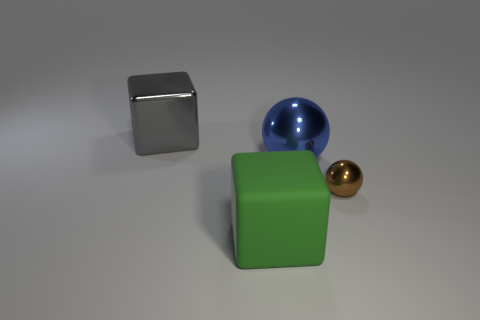Is the number of metal objects right of the large green matte object less than the number of gray shiny cubes on the right side of the small brown metal ball?
Provide a short and direct response. No. There is a thing that is left of the blue shiny thing and in front of the blue metal sphere; what is it made of?
Make the answer very short. Rubber. There is a tiny brown object; does it have the same shape as the large thing that is in front of the blue sphere?
Your answer should be compact. No. What number of other things are there of the same size as the brown metal sphere?
Offer a very short reply. 0. Are there more blue metallic things than small metal cubes?
Your answer should be very brief. Yes. How many large shiny things are left of the green object and on the right side of the big rubber block?
Your answer should be compact. 0. There is a big shiny thing to the right of the large shiny thing that is left of the large cube to the right of the gray object; what shape is it?
Provide a succinct answer. Sphere. Is there anything else that has the same shape as the large green rubber object?
Offer a terse response. Yes. What number of cylinders are brown metallic things or blue metallic things?
Your answer should be very brief. 0. The large thing on the right side of the block in front of the thing behind the blue shiny ball is made of what material?
Keep it short and to the point. Metal. 